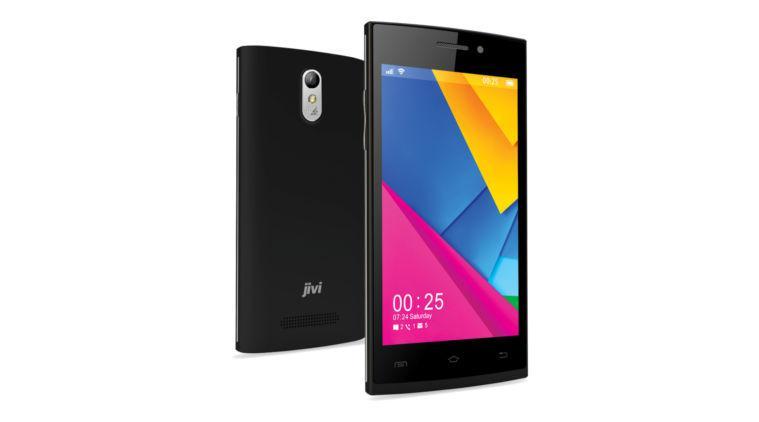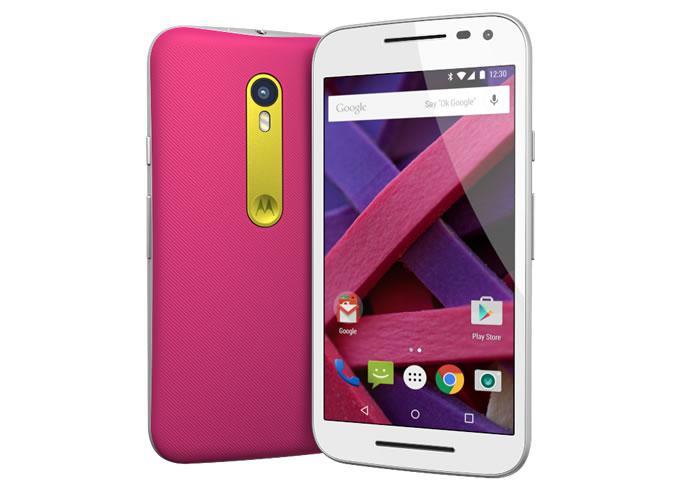The first image is the image on the left, the second image is the image on the right. Considering the images on both sides, is "there are two phones in the image pair" valid? Answer yes or no. No. The first image is the image on the left, the second image is the image on the right. Examine the images to the left and right. Is the description "There are no more than 2 phones." accurate? Answer yes or no. No. 